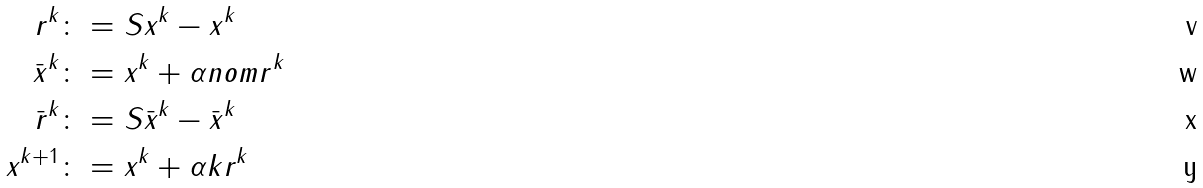<formula> <loc_0><loc_0><loc_500><loc_500>r ^ { k } & \colon = S x ^ { k } - x ^ { k } \\ \bar { x } ^ { k } & \colon = x ^ { k } + \alpha n o m r ^ { k } \\ \bar { r } ^ { k } & \colon = S \bar { x } ^ { k } - \bar { x } ^ { k } \\ x ^ { k + 1 } & \colon = x ^ { k } + \alpha k r ^ { k }</formula> 